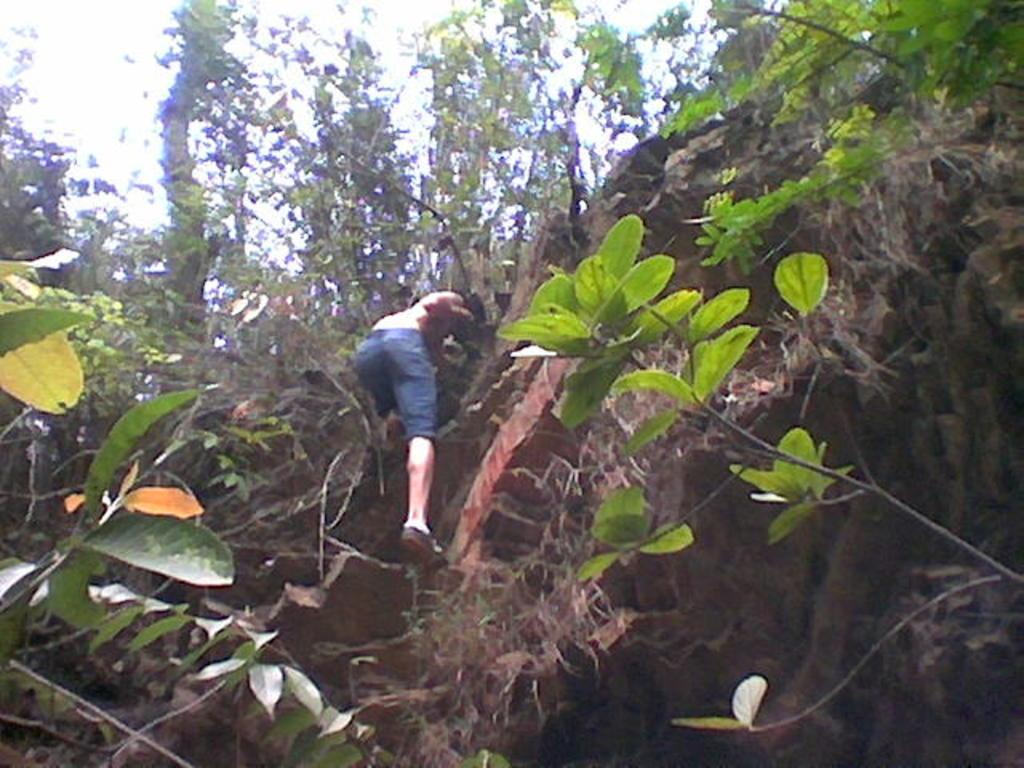What is the main subject of the image? There is a man in the image. What is the man doing in the image? The man is climbing a rock. What type of vegetation can be seen in the image? There are plants with leaves in the image. What can be seen in the background of the image? There are trees in the background of the image. What type of rose can be seen growing on the rock in the image? There is no rose present in the image; the man is climbing a rock with plants that have leaves. How many grapes can be seen hanging from the trees in the background? There are no grapes visible in the image; only trees can be seen in the background. 